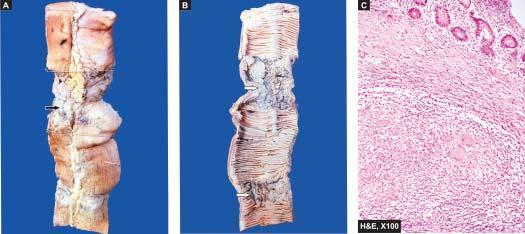does microscopy of intestine show caseating epithelioid cell granulomas in the intestinal wall?
Answer the question using a single word or phrase. Yes 